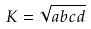Convert formula to latex. <formula><loc_0><loc_0><loc_500><loc_500>K = \sqrt { a b c d }</formula> 